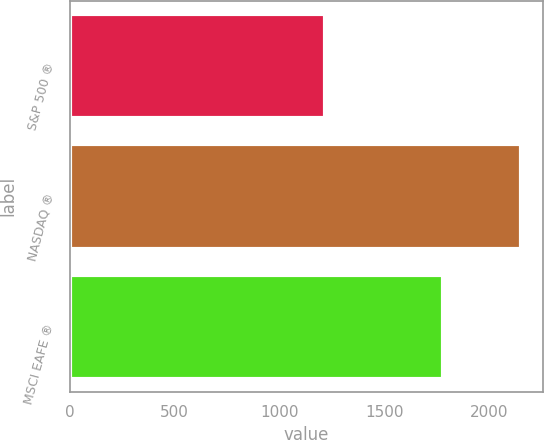Convert chart. <chart><loc_0><loc_0><loc_500><loc_500><bar_chart><fcel>S&P 500 ®<fcel>NASDAQ ®<fcel>MSCI EAFE ®<nl><fcel>1215<fcel>2149<fcel>1777<nl></chart> 